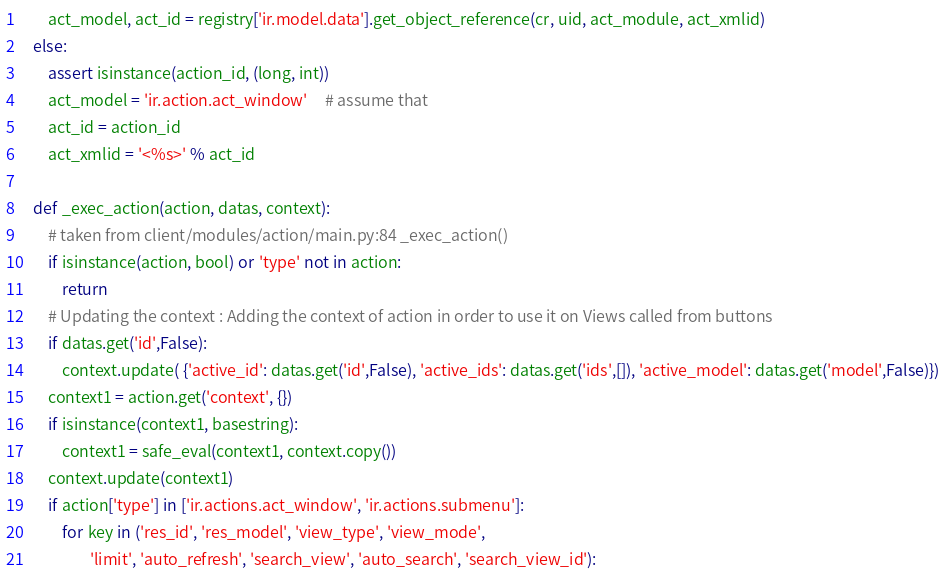<code> <loc_0><loc_0><loc_500><loc_500><_Python_>        act_model, act_id = registry['ir.model.data'].get_object_reference(cr, uid, act_module, act_xmlid)
    else:
        assert isinstance(action_id, (long, int))
        act_model = 'ir.action.act_window'     # assume that
        act_id = action_id
        act_xmlid = '<%s>' % act_id

    def _exec_action(action, datas, context):
        # taken from client/modules/action/main.py:84 _exec_action()
        if isinstance(action, bool) or 'type' not in action:
            return
        # Updating the context : Adding the context of action in order to use it on Views called from buttons
        if datas.get('id',False):
            context.update( {'active_id': datas.get('id',False), 'active_ids': datas.get('ids',[]), 'active_model': datas.get('model',False)})
        context1 = action.get('context', {})
        if isinstance(context1, basestring):
            context1 = safe_eval(context1, context.copy())
        context.update(context1)
        if action['type'] in ['ir.actions.act_window', 'ir.actions.submenu']:
            for key in ('res_id', 'res_model', 'view_type', 'view_mode',
                    'limit', 'auto_refresh', 'search_view', 'auto_search', 'search_view_id'):</code> 